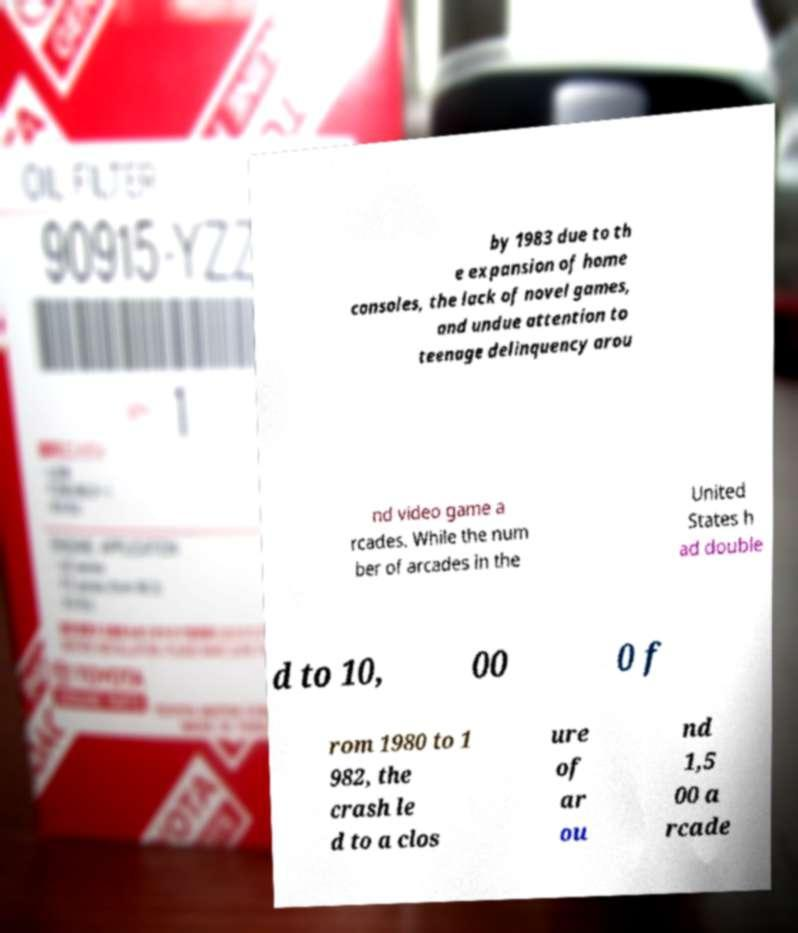What messages or text are displayed in this image? I need them in a readable, typed format. by 1983 due to th e expansion of home consoles, the lack of novel games, and undue attention to teenage delinquency arou nd video game a rcades. While the num ber of arcades in the United States h ad double d to 10, 00 0 f rom 1980 to 1 982, the crash le d to a clos ure of ar ou nd 1,5 00 a rcade 